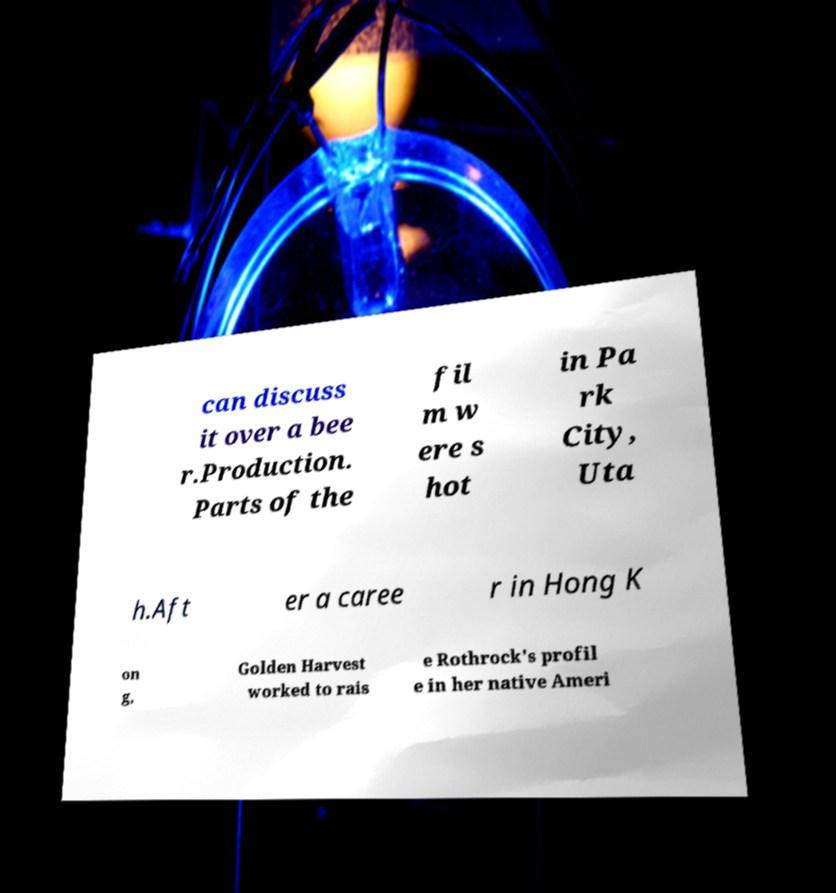What messages or text are displayed in this image? I need them in a readable, typed format. can discuss it over a bee r.Production. Parts of the fil m w ere s hot in Pa rk City, Uta h.Aft er a caree r in Hong K on g, Golden Harvest worked to rais e Rothrock's profil e in her native Ameri 